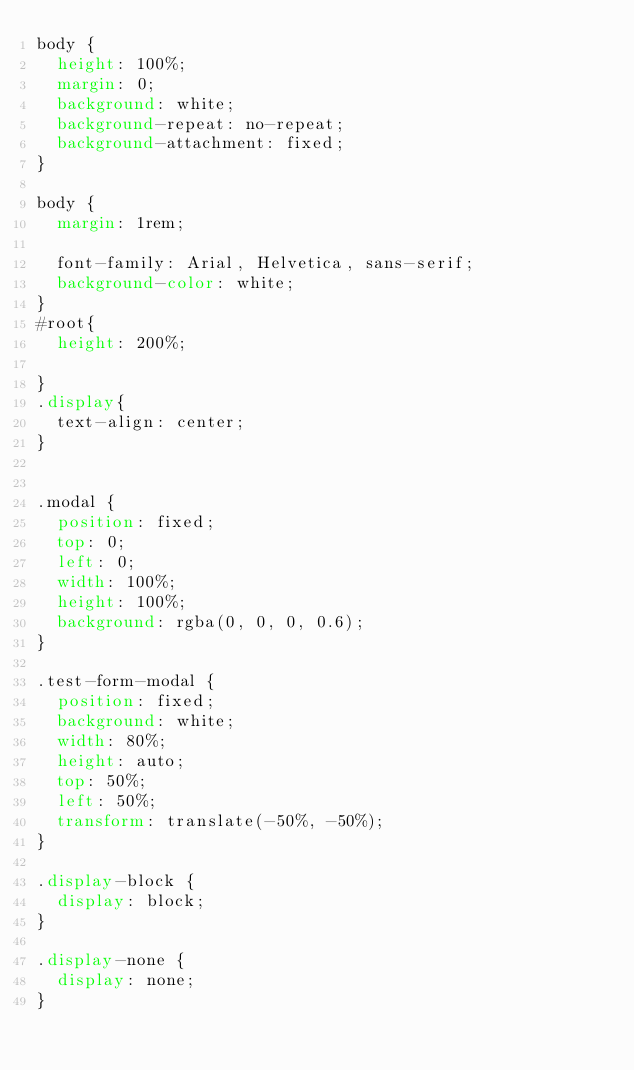Convert code to text. <code><loc_0><loc_0><loc_500><loc_500><_CSS_>body {
  height: 100%;
  margin: 0;
  background: white;
  background-repeat: no-repeat;
  background-attachment: fixed;
}

body {
  margin: 1rem;
 
  font-family: Arial, Helvetica, sans-serif;
  background-color: white;
}
#root{
  height: 200%;

}
.display{
  text-align: center;
}


.modal {
  position: fixed;
  top: 0;
  left: 0;
  width: 100%;
  height: 100%;
  background: rgba(0, 0, 0, 0.6);
}

.test-form-modal {
  position: fixed;
  background: white;
  width: 80%;
  height: auto;
  top: 50%;
  left: 50%;
  transform: translate(-50%, -50%);
}

.display-block {
  display: block;
}

.display-none {
  display: none;
}
</code> 